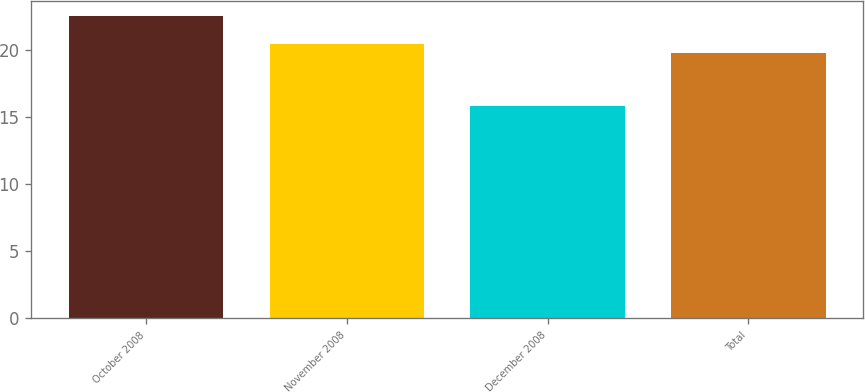<chart> <loc_0><loc_0><loc_500><loc_500><bar_chart><fcel>October 2008<fcel>November 2008<fcel>December 2008<fcel>Total<nl><fcel>22.58<fcel>20.49<fcel>15.86<fcel>19.82<nl></chart> 